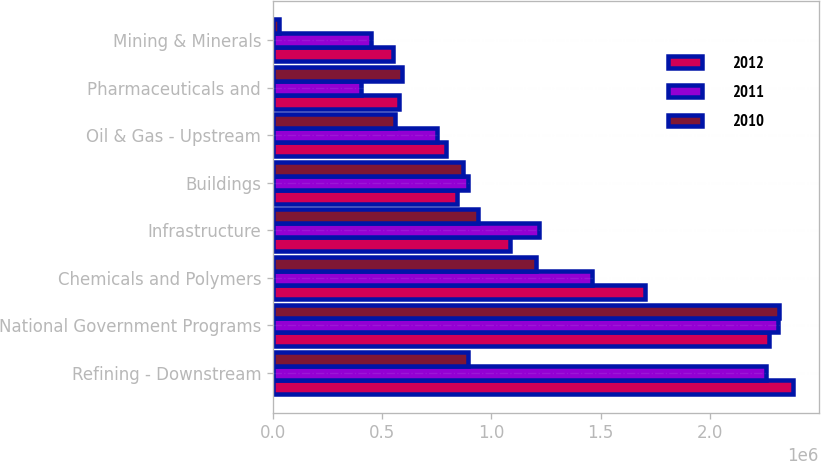Convert chart to OTSL. <chart><loc_0><loc_0><loc_500><loc_500><stacked_bar_chart><ecel><fcel>Refining - Downstream<fcel>National Government Programs<fcel>Chemicals and Polymers<fcel>Infrastructure<fcel>Buildings<fcel>Oil & Gas - Upstream<fcel>Pharmaceuticals and<fcel>Mining & Minerals<nl><fcel>2012<fcel>2.37975e+06<fcel>2.27261e+06<fcel>1.70472e+06<fcel>1.08565e+06<fcel>843938<fcel>790546<fcel>576303<fcel>550134<nl><fcel>2011<fcel>2.25609e+06<fcel>2.31324e+06<fcel>1.46112e+06<fcel>1.21963e+06<fcel>893528<fcel>753471<fcel>404687<fcel>449194<nl><fcel>2010<fcel>893528<fcel>2.31455e+06<fcel>1.20337e+06<fcel>938978<fcel>869248<fcel>559492<fcel>589795<fcel>26161<nl></chart> 